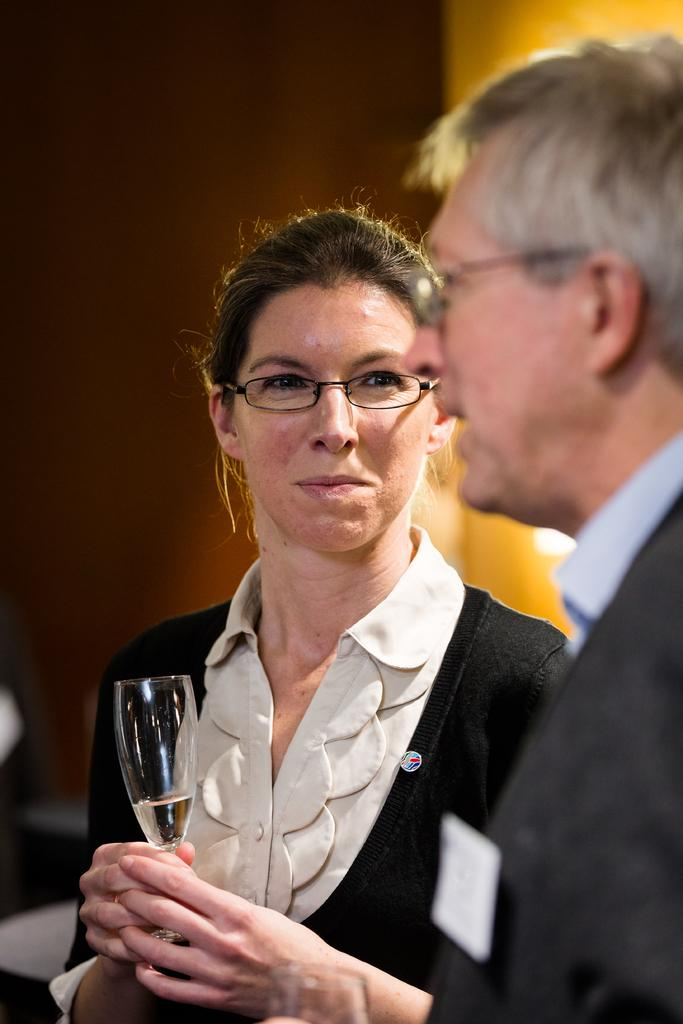Who are the people in the image? There is a woman and a man in the image. What are the woman and man holding in the image? The woman and man are holding wine glasses. What are the woman and man doing in the image? The woman and man are speaking to each other. How many thumbs can be seen on the woman's hand in the image? There is no thumb visible on the woman's hand in the image. What is the temperature of the room in the image? The temperature of the room is not mentioned in the image, so it cannot be determined. 